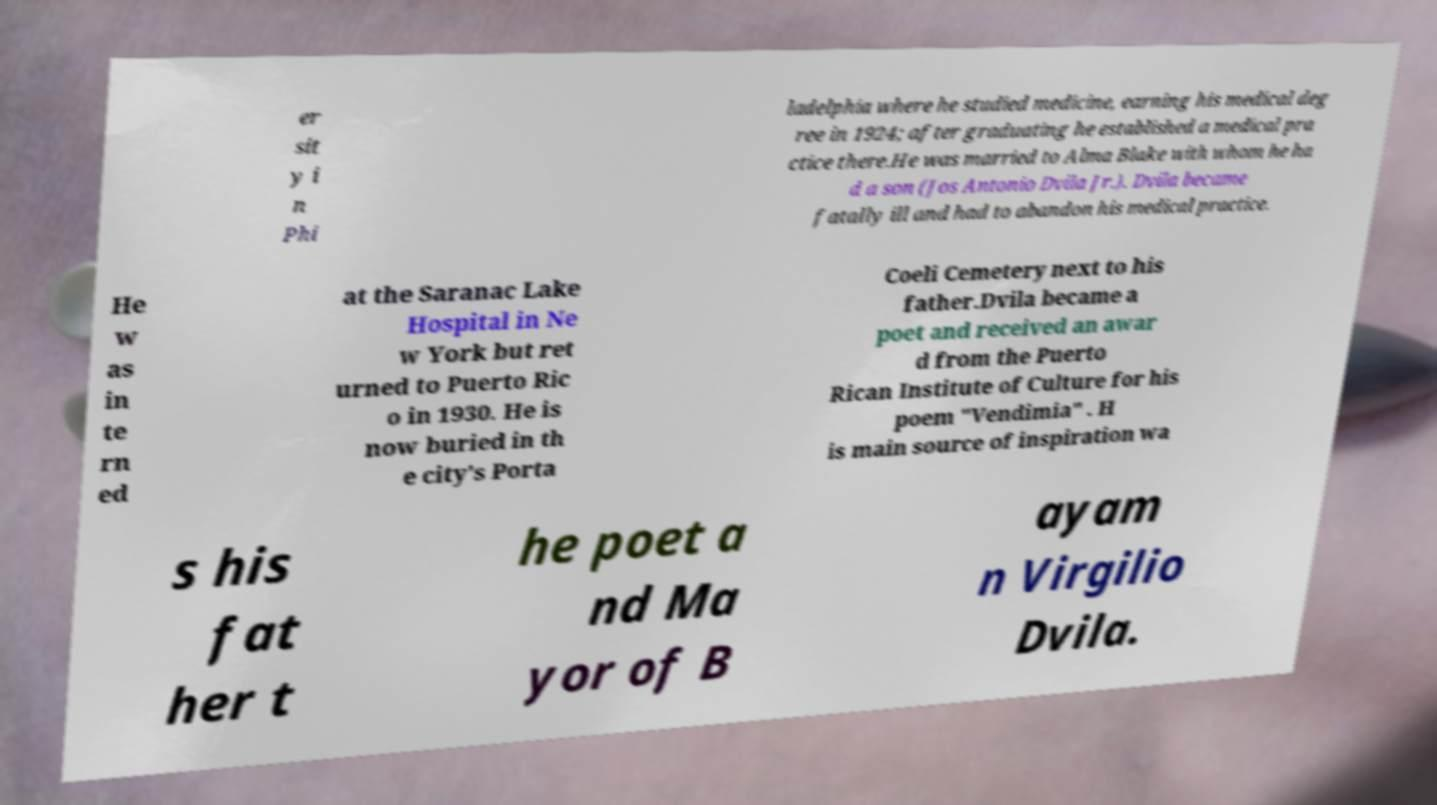Please identify and transcribe the text found in this image. er sit y i n Phi ladelphia where he studied medicine, earning his medical deg ree in 1924; after graduating he established a medical pra ctice there.He was married to Alma Blake with whom he ha d a son (Jos Antonio Dvila Jr.). Dvila became fatally ill and had to abandon his medical practice. He w as in te rn ed at the Saranac Lake Hospital in Ne w York but ret urned to Puerto Ric o in 1930. He is now buried in th e city's Porta Coeli Cemetery next to his father.Dvila became a poet and received an awar d from the Puerto Rican Institute of Culture for his poem "Vendimia" . H is main source of inspiration wa s his fat her t he poet a nd Ma yor of B ayam n Virgilio Dvila. 